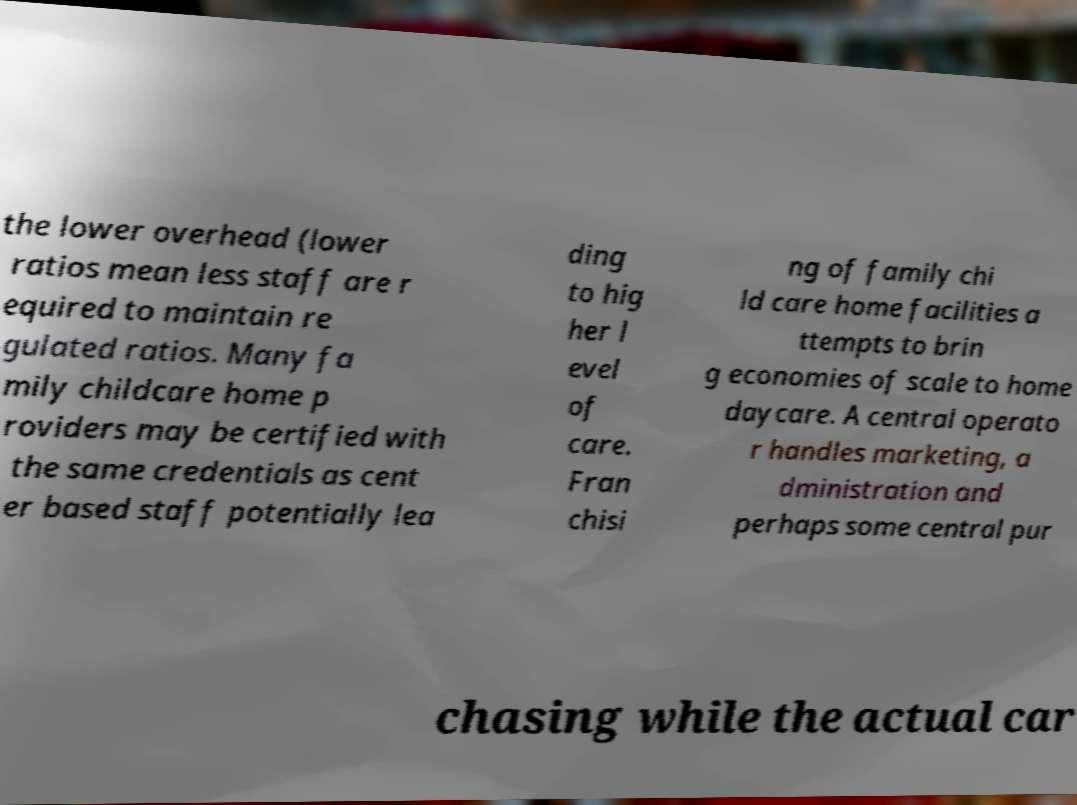Could you extract and type out the text from this image? the lower overhead (lower ratios mean less staff are r equired to maintain re gulated ratios. Many fa mily childcare home p roviders may be certified with the same credentials as cent er based staff potentially lea ding to hig her l evel of care. Fran chisi ng of family chi ld care home facilities a ttempts to brin g economies of scale to home daycare. A central operato r handles marketing, a dministration and perhaps some central pur chasing while the actual car 